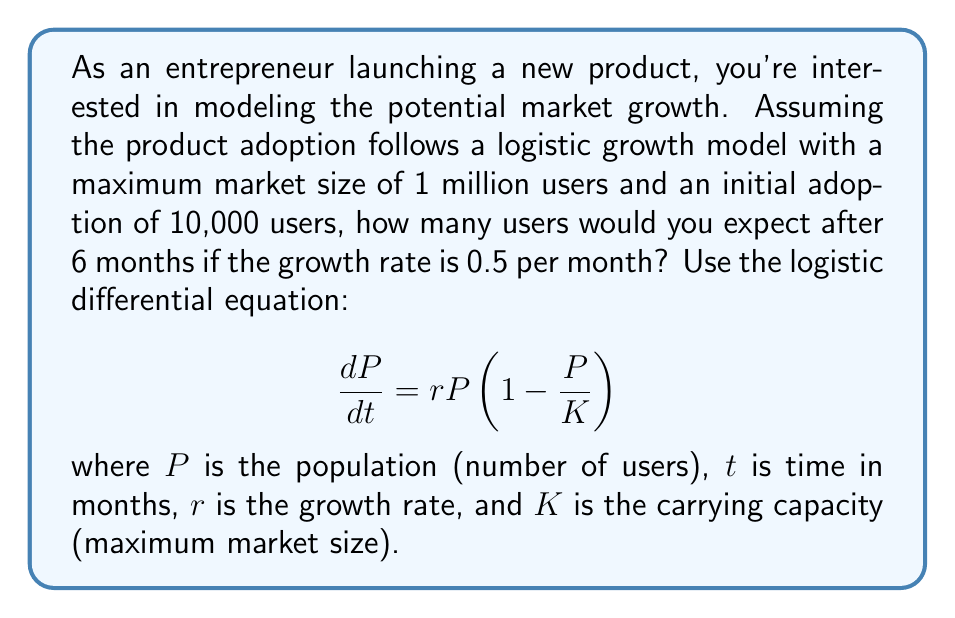Help me with this question. To solve this problem, we need to use the solution to the logistic differential equation:

$$P(t) = \frac{K}{1 + (\frac{K}{P_0} - 1)e^{-rt}}$$

Where:
$K = 1,000,000$ (carrying capacity)
$P_0 = 10,000$ (initial population)
$r = 0.5$ (growth rate per month)
$t = 6$ (time in months)

Let's substitute these values into the equation:

$$P(6) = \frac{1,000,000}{1 + (\frac{1,000,000}{10,000} - 1)e^{-0.5 \cdot 6}}$$

Simplifying:

$$P(6) = \frac{1,000,000}{1 + (99)e^{-3}}$$

Now, let's calculate $e^{-3}$:

$$e^{-3} \approx 0.0498$$

Substituting this value:

$$P(6) = \frac{1,000,000}{1 + 99 \cdot 0.0498} = \frac{1,000,000}{1 + 4.9302}$$

$$P(6) = \frac{1,000,000}{5.9302} \approx 168,628.95$$

Rounding to the nearest whole number, as we can't have fractional users:

$$P(6) \approx 168,629$$
Answer: After 6 months, you would expect approximately 168,629 users. 